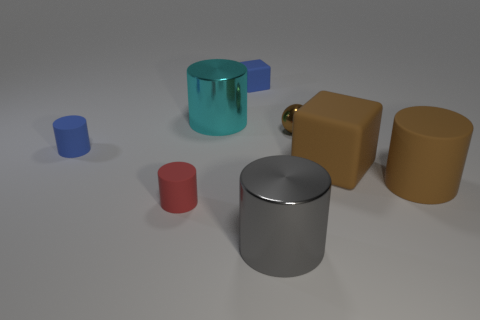How many tiny shiny spheres are on the left side of the small blue cylinder?
Make the answer very short. 0. What number of rubber cylinders are the same color as the metal sphere?
Provide a short and direct response. 1. Do the brown cylinder that is in front of the small blue block and the red object have the same material?
Ensure brevity in your answer.  Yes. What number of blue cylinders are the same material as the tiny red cylinder?
Provide a short and direct response. 1. Are there more big cylinders that are on the left side of the brown shiny ball than tiny yellow matte cubes?
Your answer should be compact. Yes. What size is the rubber cylinder that is the same color as the shiny ball?
Offer a terse response. Large. Is there another big rubber thing of the same shape as the large gray thing?
Your answer should be compact. Yes. What number of things are either gray matte balls or small spheres?
Offer a terse response. 1. How many cylinders are on the right side of the metallic cylinder in front of the blue matte object that is in front of the tiny sphere?
Make the answer very short. 1. There is a large brown thing that is the same shape as the small red rubber thing; what material is it?
Provide a succinct answer. Rubber. 